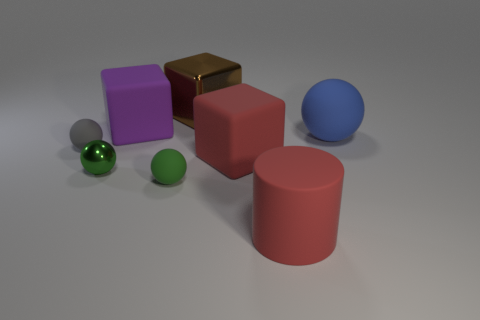Subtract 2 balls. How many balls are left? 2 Subtract all brown balls. Subtract all brown cylinders. How many balls are left? 4 Add 1 big red cubes. How many objects exist? 9 Subtract all cylinders. How many objects are left? 7 Subtract all big purple spheres. Subtract all matte cylinders. How many objects are left? 7 Add 1 rubber cylinders. How many rubber cylinders are left? 2 Add 2 large metallic cubes. How many large metallic cubes exist? 3 Subtract 1 purple cubes. How many objects are left? 7 